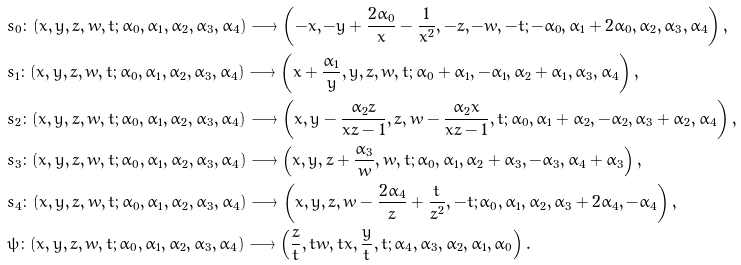<formula> <loc_0><loc_0><loc_500><loc_500>& s _ { 0 } \colon ( x , y , z , w , t ; \alpha _ { 0 } , \alpha _ { 1 } , \alpha _ { 2 } , \alpha _ { 3 } , \alpha _ { 4 } ) \longrightarrow \left ( - x , - y + \frac { 2 \alpha _ { 0 } } { x } - \frac { 1 } { x ^ { 2 } } , - z , - w , - t ; - \alpha _ { 0 } , \alpha _ { 1 } + 2 \alpha _ { 0 } , \alpha _ { 2 } , \alpha _ { 3 } , \alpha _ { 4 } \right ) , \\ & s _ { 1 } \colon ( x , y , z , w , t ; \alpha _ { 0 } , \alpha _ { 1 } , \alpha _ { 2 } , \alpha _ { 3 } , \alpha _ { 4 } ) \longrightarrow \left ( x + \frac { \alpha _ { 1 } } { y } , y , z , w , t ; \alpha _ { 0 } + \alpha _ { 1 } , - \alpha _ { 1 } , \alpha _ { 2 } + \alpha _ { 1 } , \alpha _ { 3 } , \alpha _ { 4 } \right ) , \\ & s _ { 2 } \colon ( x , y , z , w , t ; \alpha _ { 0 } , \alpha _ { 1 } , \alpha _ { 2 } , \alpha _ { 3 } , \alpha _ { 4 } ) \longrightarrow \left ( x , y - \frac { \alpha _ { 2 } z } { x z - 1 } , z , w - \frac { \alpha _ { 2 } x } { x z - 1 } , t ; \alpha _ { 0 } , \alpha _ { 1 } + \alpha _ { 2 } , - \alpha _ { 2 } , \alpha _ { 3 } + \alpha _ { 2 } , \alpha _ { 4 } \right ) , \\ & s _ { 3 } \colon ( x , y , z , w , t ; \alpha _ { 0 } , \alpha _ { 1 } , \alpha _ { 2 } , \alpha _ { 3 } , \alpha _ { 4 } ) \longrightarrow \left ( x , y , z + \frac { \alpha _ { 3 } } { w } , w , t ; \alpha _ { 0 } , \alpha _ { 1 } , \alpha _ { 2 } + \alpha _ { 3 } , - \alpha _ { 3 } , \alpha _ { 4 } + \alpha _ { 3 } \right ) , \\ & s _ { 4 } \colon ( x , y , z , w , t ; \alpha _ { 0 } , \alpha _ { 1 } , \alpha _ { 2 } , \alpha _ { 3 } , \alpha _ { 4 } ) \longrightarrow \left ( x , y , z , w - \frac { 2 \alpha _ { 4 } } { z } + \frac { t } { z ^ { 2 } } , - t ; \alpha _ { 0 } , \alpha _ { 1 } , \alpha _ { 2 } , \alpha _ { 3 } + 2 \alpha _ { 4 } , - \alpha _ { 4 } \right ) , \\ & \psi \colon ( x , y , z , w , t ; \alpha _ { 0 } , \alpha _ { 1 } , \alpha _ { 2 } , \alpha _ { 3 } , \alpha _ { 4 } ) \longrightarrow \left ( \frac { z } { t } , t w , t x , \frac { y } { t } , t ; \alpha _ { 4 } , \alpha _ { 3 } , \alpha _ { 2 } , \alpha _ { 1 } , \alpha _ { 0 } \right ) .</formula> 